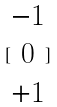Convert formula to latex. <formula><loc_0><loc_0><loc_500><loc_500>[ \begin{matrix} - 1 \\ 0 \\ + 1 \end{matrix} ]</formula> 